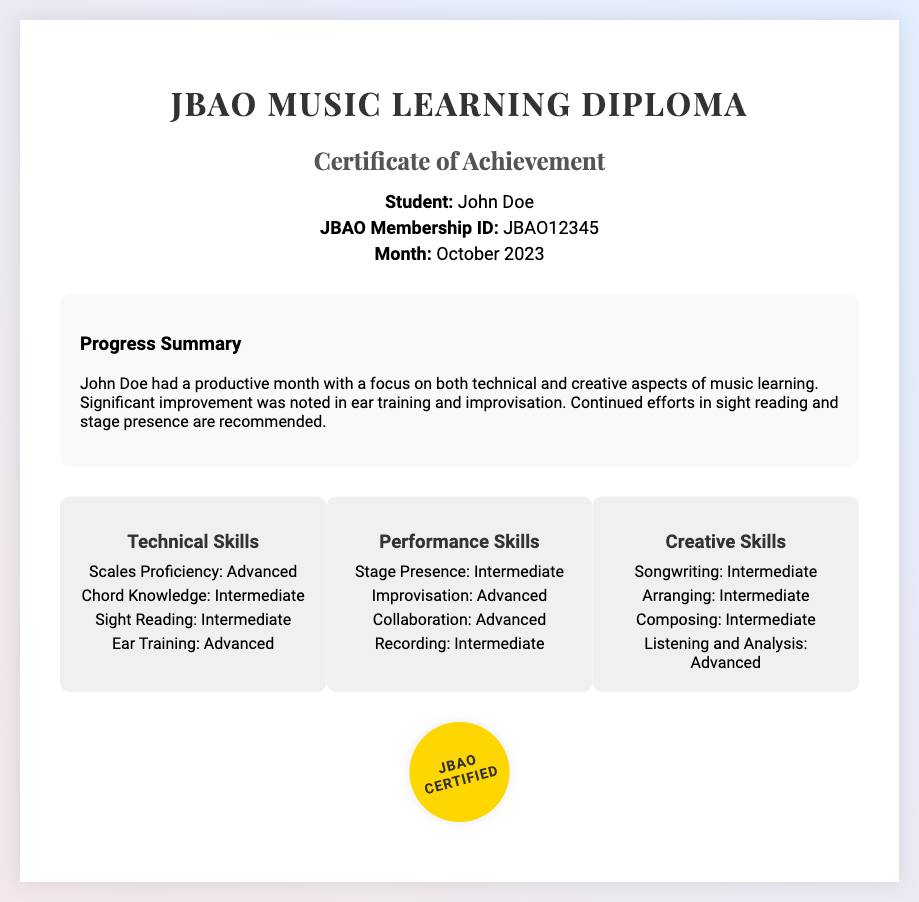what is the student's name? The document provides the name of the student in the student info section, which is clearly stated.
Answer: John Doe what is the JBAO Membership ID? The JBAO Membership ID is listed in the student info section of the document.
Answer: JBAO12345 what month is reported in the diploma? The month mentioned in the student info section indicates the specific reporting period for achievements.
Answer: October 2023 what is the overall area of focus in music learning? The progress summary highlights key areas of focus for the student’s improvement.
Answer: Technical and creative aspects which skill is advanced in Technical Skills? The document lists levels of proficiency for various skills, specifying which are advanced.
Answer: Scales Proficiency what are the two areas where significant improvement was noted? The progress summary notes improvements in specific skills, requiring synthesis of that information.
Answer: Ear training and improvisation what is the skill level for improvisation in Performance Skills? The skill levels are categorized. The Performance Skills section specifies this.
Answer: Advanced which creative skill is noted as advanced? The Creative Skills section outlines skill levels, indicating which skills are advanced.
Answer: Listening and Analysis what is recommended for continuous effort according to the progress report? The progress summary provides suggestions for areas that require continued focus.
Answer: Sight reading and stage presence 